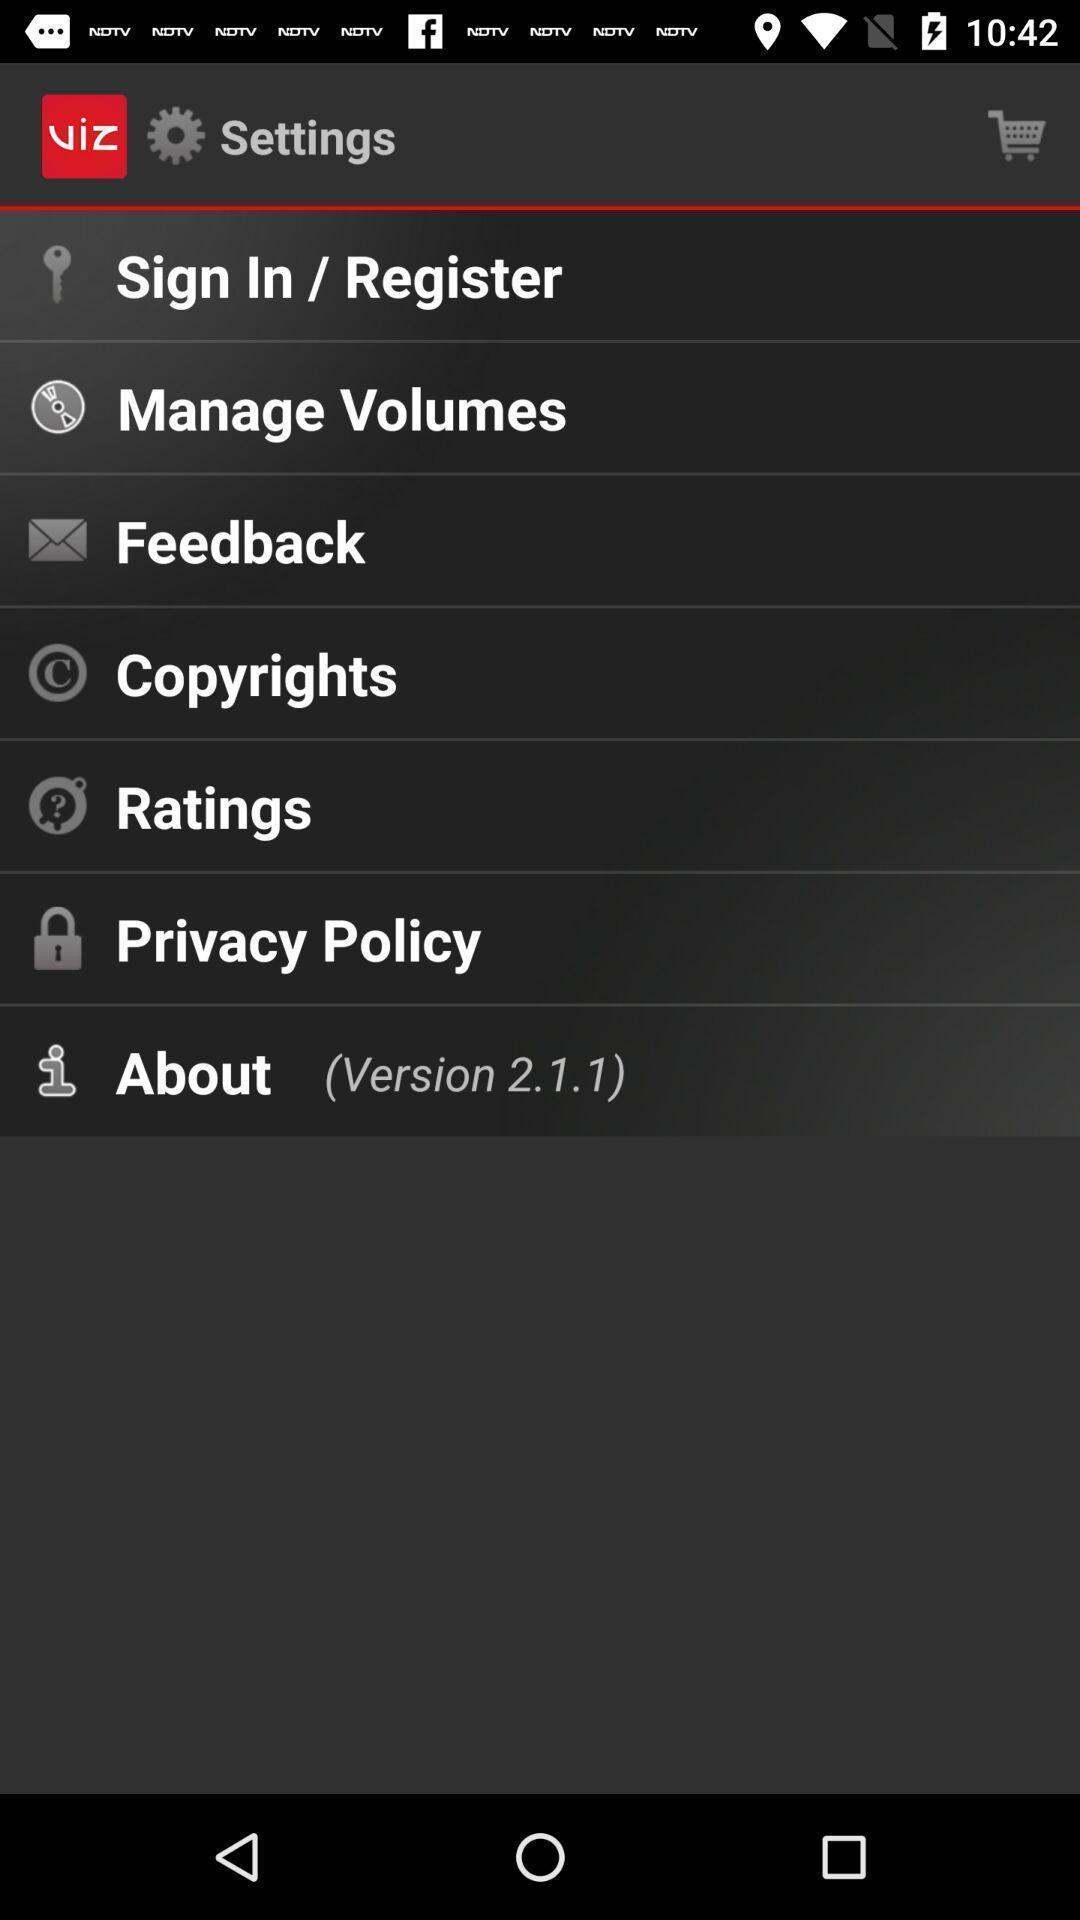Explain the elements present in this screenshot. Settings page. 